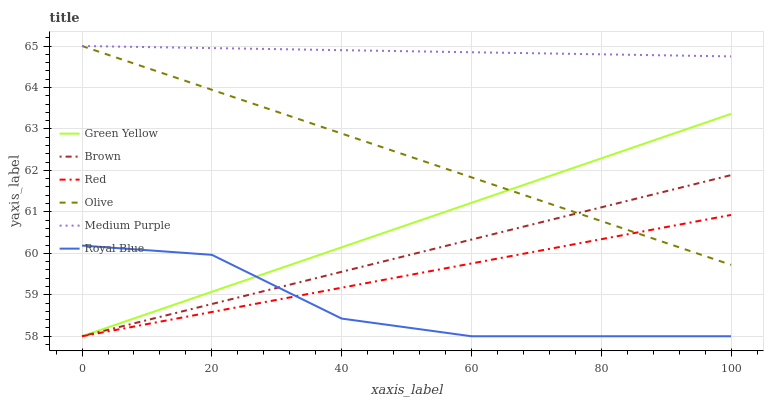Does Royal Blue have the minimum area under the curve?
Answer yes or no. Yes. Does Medium Purple have the maximum area under the curve?
Answer yes or no. Yes. Does Medium Purple have the minimum area under the curve?
Answer yes or no. No. Does Royal Blue have the maximum area under the curve?
Answer yes or no. No. Is Green Yellow the smoothest?
Answer yes or no. Yes. Is Royal Blue the roughest?
Answer yes or no. Yes. Is Medium Purple the smoothest?
Answer yes or no. No. Is Medium Purple the roughest?
Answer yes or no. No. Does Brown have the lowest value?
Answer yes or no. Yes. Does Medium Purple have the lowest value?
Answer yes or no. No. Does Olive have the highest value?
Answer yes or no. Yes. Does Royal Blue have the highest value?
Answer yes or no. No. Is Royal Blue less than Medium Purple?
Answer yes or no. Yes. Is Olive greater than Royal Blue?
Answer yes or no. Yes. Does Olive intersect Red?
Answer yes or no. Yes. Is Olive less than Red?
Answer yes or no. No. Is Olive greater than Red?
Answer yes or no. No. Does Royal Blue intersect Medium Purple?
Answer yes or no. No. 